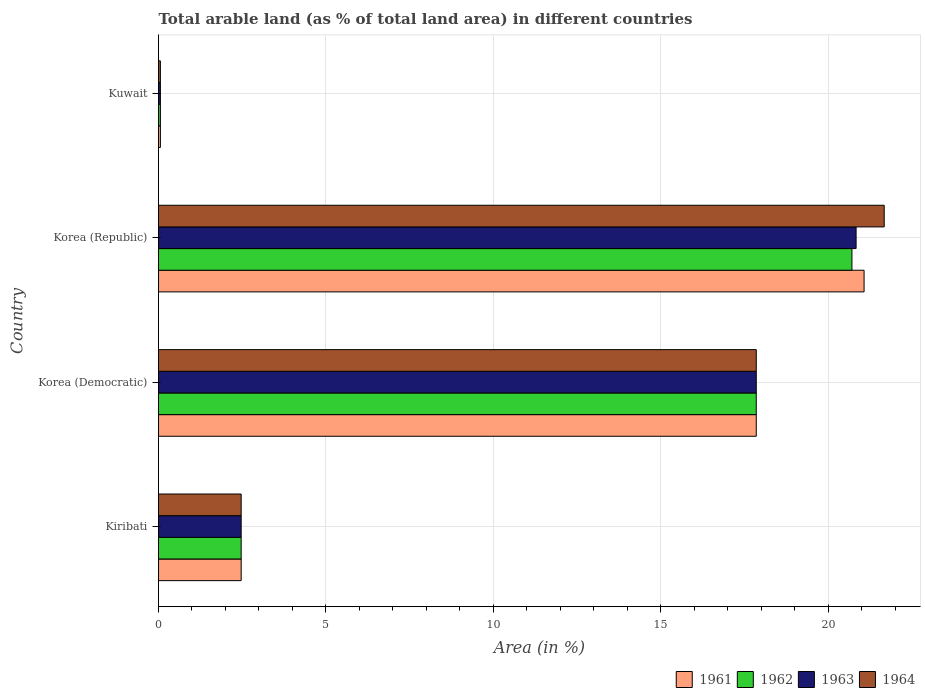How many different coloured bars are there?
Provide a short and direct response. 4. How many groups of bars are there?
Offer a very short reply. 4. Are the number of bars per tick equal to the number of legend labels?
Provide a short and direct response. Yes. Are the number of bars on each tick of the Y-axis equal?
Your response must be concise. Yes. How many bars are there on the 1st tick from the top?
Provide a short and direct response. 4. How many bars are there on the 3rd tick from the bottom?
Keep it short and to the point. 4. What is the label of the 3rd group of bars from the top?
Your answer should be compact. Korea (Democratic). In how many cases, is the number of bars for a given country not equal to the number of legend labels?
Your answer should be compact. 0. What is the percentage of arable land in 1964 in Kuwait?
Provide a succinct answer. 0.06. Across all countries, what is the maximum percentage of arable land in 1962?
Keep it short and to the point. 20.71. Across all countries, what is the minimum percentage of arable land in 1964?
Ensure brevity in your answer.  0.06. In which country was the percentage of arable land in 1964 maximum?
Provide a short and direct response. Korea (Republic). In which country was the percentage of arable land in 1962 minimum?
Your answer should be very brief. Kuwait. What is the total percentage of arable land in 1963 in the graph?
Keep it short and to the point. 41.22. What is the difference between the percentage of arable land in 1964 in Kiribati and that in Korea (Republic)?
Ensure brevity in your answer.  -19.21. What is the difference between the percentage of arable land in 1961 in Kuwait and the percentage of arable land in 1963 in Korea (Republic)?
Keep it short and to the point. -20.78. What is the average percentage of arable land in 1964 per country?
Offer a terse response. 10.51. What is the difference between the percentage of arable land in 1961 and percentage of arable land in 1963 in Kuwait?
Provide a short and direct response. 0. What is the ratio of the percentage of arable land in 1962 in Kiribati to that in Korea (Democratic)?
Keep it short and to the point. 0.14. Is the difference between the percentage of arable land in 1961 in Kiribati and Korea (Republic) greater than the difference between the percentage of arable land in 1963 in Kiribati and Korea (Republic)?
Give a very brief answer. No. What is the difference between the highest and the second highest percentage of arable land in 1962?
Your answer should be very brief. 2.86. What is the difference between the highest and the lowest percentage of arable land in 1963?
Give a very brief answer. 20.78. Is it the case that in every country, the sum of the percentage of arable land in 1964 and percentage of arable land in 1961 is greater than the sum of percentage of arable land in 1963 and percentage of arable land in 1962?
Offer a terse response. No. What does the 4th bar from the bottom in Korea (Democratic) represents?
Provide a succinct answer. 1964. How many bars are there?
Ensure brevity in your answer.  16. Are all the bars in the graph horizontal?
Provide a succinct answer. Yes. What is the difference between two consecutive major ticks on the X-axis?
Offer a very short reply. 5. Does the graph contain any zero values?
Make the answer very short. No. Where does the legend appear in the graph?
Provide a short and direct response. Bottom right. How are the legend labels stacked?
Your answer should be compact. Horizontal. What is the title of the graph?
Your answer should be compact. Total arable land (as % of total land area) in different countries. What is the label or title of the X-axis?
Give a very brief answer. Area (in %). What is the Area (in %) in 1961 in Kiribati?
Keep it short and to the point. 2.47. What is the Area (in %) of 1962 in Kiribati?
Ensure brevity in your answer.  2.47. What is the Area (in %) of 1963 in Kiribati?
Your answer should be compact. 2.47. What is the Area (in %) in 1964 in Kiribati?
Your answer should be very brief. 2.47. What is the Area (in %) of 1961 in Korea (Democratic)?
Your answer should be compact. 17.86. What is the Area (in %) of 1962 in Korea (Democratic)?
Offer a very short reply. 17.86. What is the Area (in %) of 1963 in Korea (Democratic)?
Give a very brief answer. 17.86. What is the Area (in %) of 1964 in Korea (Democratic)?
Provide a succinct answer. 17.86. What is the Area (in %) of 1961 in Korea (Republic)?
Provide a succinct answer. 21.08. What is the Area (in %) in 1962 in Korea (Republic)?
Your response must be concise. 20.71. What is the Area (in %) of 1963 in Korea (Republic)?
Provide a succinct answer. 20.84. What is the Area (in %) in 1964 in Korea (Republic)?
Give a very brief answer. 21.68. What is the Area (in %) of 1961 in Kuwait?
Keep it short and to the point. 0.06. What is the Area (in %) in 1962 in Kuwait?
Provide a succinct answer. 0.06. What is the Area (in %) in 1963 in Kuwait?
Your answer should be compact. 0.06. What is the Area (in %) of 1964 in Kuwait?
Ensure brevity in your answer.  0.06. Across all countries, what is the maximum Area (in %) in 1961?
Keep it short and to the point. 21.08. Across all countries, what is the maximum Area (in %) in 1962?
Offer a very short reply. 20.71. Across all countries, what is the maximum Area (in %) in 1963?
Offer a very short reply. 20.84. Across all countries, what is the maximum Area (in %) of 1964?
Your answer should be very brief. 21.68. Across all countries, what is the minimum Area (in %) in 1961?
Provide a short and direct response. 0.06. Across all countries, what is the minimum Area (in %) of 1962?
Offer a very short reply. 0.06. Across all countries, what is the minimum Area (in %) of 1963?
Your answer should be very brief. 0.06. Across all countries, what is the minimum Area (in %) in 1964?
Your answer should be compact. 0.06. What is the total Area (in %) of 1961 in the graph?
Your answer should be compact. 41.46. What is the total Area (in %) of 1962 in the graph?
Your answer should be compact. 41.09. What is the total Area (in %) in 1963 in the graph?
Your answer should be very brief. 41.22. What is the total Area (in %) in 1964 in the graph?
Ensure brevity in your answer.  42.06. What is the difference between the Area (in %) of 1961 in Kiribati and that in Korea (Democratic)?
Your response must be concise. -15.39. What is the difference between the Area (in %) in 1962 in Kiribati and that in Korea (Democratic)?
Your answer should be very brief. -15.39. What is the difference between the Area (in %) in 1963 in Kiribati and that in Korea (Democratic)?
Your response must be concise. -15.39. What is the difference between the Area (in %) in 1964 in Kiribati and that in Korea (Democratic)?
Provide a short and direct response. -15.39. What is the difference between the Area (in %) in 1961 in Kiribati and that in Korea (Republic)?
Your answer should be compact. -18.61. What is the difference between the Area (in %) of 1962 in Kiribati and that in Korea (Republic)?
Give a very brief answer. -18.24. What is the difference between the Area (in %) in 1963 in Kiribati and that in Korea (Republic)?
Make the answer very short. -18.37. What is the difference between the Area (in %) in 1964 in Kiribati and that in Korea (Republic)?
Offer a very short reply. -19.21. What is the difference between the Area (in %) of 1961 in Kiribati and that in Kuwait?
Your answer should be compact. 2.41. What is the difference between the Area (in %) in 1962 in Kiribati and that in Kuwait?
Keep it short and to the point. 2.41. What is the difference between the Area (in %) of 1963 in Kiribati and that in Kuwait?
Offer a very short reply. 2.41. What is the difference between the Area (in %) of 1964 in Kiribati and that in Kuwait?
Offer a very short reply. 2.41. What is the difference between the Area (in %) of 1961 in Korea (Democratic) and that in Korea (Republic)?
Ensure brevity in your answer.  -3.22. What is the difference between the Area (in %) of 1962 in Korea (Democratic) and that in Korea (Republic)?
Your response must be concise. -2.86. What is the difference between the Area (in %) in 1963 in Korea (Democratic) and that in Korea (Republic)?
Provide a short and direct response. -2.98. What is the difference between the Area (in %) of 1964 in Korea (Democratic) and that in Korea (Republic)?
Offer a terse response. -3.82. What is the difference between the Area (in %) in 1961 in Korea (Democratic) and that in Kuwait?
Your answer should be compact. 17.8. What is the difference between the Area (in %) in 1962 in Korea (Democratic) and that in Kuwait?
Offer a terse response. 17.8. What is the difference between the Area (in %) of 1963 in Korea (Democratic) and that in Kuwait?
Offer a terse response. 17.8. What is the difference between the Area (in %) of 1964 in Korea (Democratic) and that in Kuwait?
Make the answer very short. 17.8. What is the difference between the Area (in %) of 1961 in Korea (Republic) and that in Kuwait?
Your answer should be compact. 21.02. What is the difference between the Area (in %) of 1962 in Korea (Republic) and that in Kuwait?
Provide a succinct answer. 20.66. What is the difference between the Area (in %) in 1963 in Korea (Republic) and that in Kuwait?
Keep it short and to the point. 20.78. What is the difference between the Area (in %) of 1964 in Korea (Republic) and that in Kuwait?
Provide a succinct answer. 21.62. What is the difference between the Area (in %) of 1961 in Kiribati and the Area (in %) of 1962 in Korea (Democratic)?
Give a very brief answer. -15.39. What is the difference between the Area (in %) of 1961 in Kiribati and the Area (in %) of 1963 in Korea (Democratic)?
Keep it short and to the point. -15.39. What is the difference between the Area (in %) of 1961 in Kiribati and the Area (in %) of 1964 in Korea (Democratic)?
Your answer should be very brief. -15.39. What is the difference between the Area (in %) of 1962 in Kiribati and the Area (in %) of 1963 in Korea (Democratic)?
Give a very brief answer. -15.39. What is the difference between the Area (in %) of 1962 in Kiribati and the Area (in %) of 1964 in Korea (Democratic)?
Your response must be concise. -15.39. What is the difference between the Area (in %) in 1963 in Kiribati and the Area (in %) in 1964 in Korea (Democratic)?
Give a very brief answer. -15.39. What is the difference between the Area (in %) in 1961 in Kiribati and the Area (in %) in 1962 in Korea (Republic)?
Provide a short and direct response. -18.24. What is the difference between the Area (in %) in 1961 in Kiribati and the Area (in %) in 1963 in Korea (Republic)?
Keep it short and to the point. -18.37. What is the difference between the Area (in %) in 1961 in Kiribati and the Area (in %) in 1964 in Korea (Republic)?
Offer a terse response. -19.21. What is the difference between the Area (in %) of 1962 in Kiribati and the Area (in %) of 1963 in Korea (Republic)?
Your answer should be compact. -18.37. What is the difference between the Area (in %) in 1962 in Kiribati and the Area (in %) in 1964 in Korea (Republic)?
Your answer should be very brief. -19.21. What is the difference between the Area (in %) of 1963 in Kiribati and the Area (in %) of 1964 in Korea (Republic)?
Offer a terse response. -19.21. What is the difference between the Area (in %) in 1961 in Kiribati and the Area (in %) in 1962 in Kuwait?
Your answer should be compact. 2.41. What is the difference between the Area (in %) of 1961 in Kiribati and the Area (in %) of 1963 in Kuwait?
Offer a very short reply. 2.41. What is the difference between the Area (in %) in 1961 in Kiribati and the Area (in %) in 1964 in Kuwait?
Provide a short and direct response. 2.41. What is the difference between the Area (in %) in 1962 in Kiribati and the Area (in %) in 1963 in Kuwait?
Your answer should be compact. 2.41. What is the difference between the Area (in %) of 1962 in Kiribati and the Area (in %) of 1964 in Kuwait?
Offer a terse response. 2.41. What is the difference between the Area (in %) in 1963 in Kiribati and the Area (in %) in 1964 in Kuwait?
Your answer should be compact. 2.41. What is the difference between the Area (in %) of 1961 in Korea (Democratic) and the Area (in %) of 1962 in Korea (Republic)?
Provide a short and direct response. -2.86. What is the difference between the Area (in %) in 1961 in Korea (Democratic) and the Area (in %) in 1963 in Korea (Republic)?
Ensure brevity in your answer.  -2.98. What is the difference between the Area (in %) of 1961 in Korea (Democratic) and the Area (in %) of 1964 in Korea (Republic)?
Provide a succinct answer. -3.82. What is the difference between the Area (in %) of 1962 in Korea (Democratic) and the Area (in %) of 1963 in Korea (Republic)?
Give a very brief answer. -2.98. What is the difference between the Area (in %) in 1962 in Korea (Democratic) and the Area (in %) in 1964 in Korea (Republic)?
Keep it short and to the point. -3.82. What is the difference between the Area (in %) of 1963 in Korea (Democratic) and the Area (in %) of 1964 in Korea (Republic)?
Provide a succinct answer. -3.82. What is the difference between the Area (in %) of 1961 in Korea (Democratic) and the Area (in %) of 1962 in Kuwait?
Your answer should be very brief. 17.8. What is the difference between the Area (in %) of 1961 in Korea (Democratic) and the Area (in %) of 1963 in Kuwait?
Give a very brief answer. 17.8. What is the difference between the Area (in %) of 1961 in Korea (Democratic) and the Area (in %) of 1964 in Kuwait?
Ensure brevity in your answer.  17.8. What is the difference between the Area (in %) of 1962 in Korea (Democratic) and the Area (in %) of 1963 in Kuwait?
Give a very brief answer. 17.8. What is the difference between the Area (in %) in 1962 in Korea (Democratic) and the Area (in %) in 1964 in Kuwait?
Ensure brevity in your answer.  17.8. What is the difference between the Area (in %) of 1963 in Korea (Democratic) and the Area (in %) of 1964 in Kuwait?
Keep it short and to the point. 17.8. What is the difference between the Area (in %) in 1961 in Korea (Republic) and the Area (in %) in 1962 in Kuwait?
Offer a very short reply. 21.02. What is the difference between the Area (in %) of 1961 in Korea (Republic) and the Area (in %) of 1963 in Kuwait?
Ensure brevity in your answer.  21.02. What is the difference between the Area (in %) in 1961 in Korea (Republic) and the Area (in %) in 1964 in Kuwait?
Ensure brevity in your answer.  21.02. What is the difference between the Area (in %) in 1962 in Korea (Republic) and the Area (in %) in 1963 in Kuwait?
Your response must be concise. 20.66. What is the difference between the Area (in %) in 1962 in Korea (Republic) and the Area (in %) in 1964 in Kuwait?
Offer a terse response. 20.66. What is the difference between the Area (in %) of 1963 in Korea (Republic) and the Area (in %) of 1964 in Kuwait?
Ensure brevity in your answer.  20.78. What is the average Area (in %) of 1961 per country?
Offer a very short reply. 10.36. What is the average Area (in %) in 1962 per country?
Provide a succinct answer. 10.27. What is the average Area (in %) of 1963 per country?
Make the answer very short. 10.3. What is the average Area (in %) of 1964 per country?
Make the answer very short. 10.51. What is the difference between the Area (in %) in 1961 and Area (in %) in 1964 in Kiribati?
Ensure brevity in your answer.  0. What is the difference between the Area (in %) in 1962 and Area (in %) in 1964 in Kiribati?
Offer a terse response. 0. What is the difference between the Area (in %) in 1961 and Area (in %) in 1963 in Korea (Democratic)?
Offer a terse response. 0. What is the difference between the Area (in %) in 1962 and Area (in %) in 1963 in Korea (Democratic)?
Your answer should be compact. 0. What is the difference between the Area (in %) of 1963 and Area (in %) of 1964 in Korea (Democratic)?
Give a very brief answer. 0. What is the difference between the Area (in %) in 1961 and Area (in %) in 1962 in Korea (Republic)?
Ensure brevity in your answer.  0.36. What is the difference between the Area (in %) in 1961 and Area (in %) in 1963 in Korea (Republic)?
Provide a succinct answer. 0.24. What is the difference between the Area (in %) in 1961 and Area (in %) in 1964 in Korea (Republic)?
Provide a short and direct response. -0.6. What is the difference between the Area (in %) of 1962 and Area (in %) of 1963 in Korea (Republic)?
Keep it short and to the point. -0.12. What is the difference between the Area (in %) in 1962 and Area (in %) in 1964 in Korea (Republic)?
Your answer should be compact. -0.96. What is the difference between the Area (in %) of 1963 and Area (in %) of 1964 in Korea (Republic)?
Your answer should be very brief. -0.84. What is the difference between the Area (in %) of 1961 and Area (in %) of 1962 in Kuwait?
Your answer should be compact. 0. What is the difference between the Area (in %) in 1962 and Area (in %) in 1964 in Kuwait?
Give a very brief answer. 0. What is the difference between the Area (in %) of 1963 and Area (in %) of 1964 in Kuwait?
Provide a short and direct response. 0. What is the ratio of the Area (in %) in 1961 in Kiribati to that in Korea (Democratic)?
Give a very brief answer. 0.14. What is the ratio of the Area (in %) in 1962 in Kiribati to that in Korea (Democratic)?
Your answer should be very brief. 0.14. What is the ratio of the Area (in %) of 1963 in Kiribati to that in Korea (Democratic)?
Ensure brevity in your answer.  0.14. What is the ratio of the Area (in %) in 1964 in Kiribati to that in Korea (Democratic)?
Ensure brevity in your answer.  0.14. What is the ratio of the Area (in %) of 1961 in Kiribati to that in Korea (Republic)?
Provide a succinct answer. 0.12. What is the ratio of the Area (in %) in 1962 in Kiribati to that in Korea (Republic)?
Your response must be concise. 0.12. What is the ratio of the Area (in %) in 1963 in Kiribati to that in Korea (Republic)?
Ensure brevity in your answer.  0.12. What is the ratio of the Area (in %) in 1964 in Kiribati to that in Korea (Republic)?
Your answer should be very brief. 0.11. What is the ratio of the Area (in %) of 1961 in Kiribati to that in Kuwait?
Offer a terse response. 44. What is the ratio of the Area (in %) of 1964 in Kiribati to that in Kuwait?
Offer a very short reply. 44. What is the ratio of the Area (in %) of 1961 in Korea (Democratic) to that in Korea (Republic)?
Provide a short and direct response. 0.85. What is the ratio of the Area (in %) in 1962 in Korea (Democratic) to that in Korea (Republic)?
Provide a succinct answer. 0.86. What is the ratio of the Area (in %) in 1963 in Korea (Democratic) to that in Korea (Republic)?
Your answer should be compact. 0.86. What is the ratio of the Area (in %) in 1964 in Korea (Democratic) to that in Korea (Republic)?
Your answer should be very brief. 0.82. What is the ratio of the Area (in %) in 1961 in Korea (Democratic) to that in Kuwait?
Provide a succinct answer. 318.19. What is the ratio of the Area (in %) in 1962 in Korea (Democratic) to that in Kuwait?
Keep it short and to the point. 318.19. What is the ratio of the Area (in %) in 1963 in Korea (Democratic) to that in Kuwait?
Make the answer very short. 318.19. What is the ratio of the Area (in %) of 1964 in Korea (Democratic) to that in Kuwait?
Offer a very short reply. 318.19. What is the ratio of the Area (in %) in 1961 in Korea (Republic) to that in Kuwait?
Make the answer very short. 375.58. What is the ratio of the Area (in %) in 1962 in Korea (Republic) to that in Kuwait?
Provide a succinct answer. 369.11. What is the ratio of the Area (in %) in 1963 in Korea (Republic) to that in Kuwait?
Offer a very short reply. 371.33. What is the ratio of the Area (in %) of 1964 in Korea (Republic) to that in Kuwait?
Ensure brevity in your answer.  386.29. What is the difference between the highest and the second highest Area (in %) in 1961?
Provide a succinct answer. 3.22. What is the difference between the highest and the second highest Area (in %) in 1962?
Provide a succinct answer. 2.86. What is the difference between the highest and the second highest Area (in %) of 1963?
Keep it short and to the point. 2.98. What is the difference between the highest and the second highest Area (in %) of 1964?
Give a very brief answer. 3.82. What is the difference between the highest and the lowest Area (in %) in 1961?
Provide a short and direct response. 21.02. What is the difference between the highest and the lowest Area (in %) in 1962?
Provide a succinct answer. 20.66. What is the difference between the highest and the lowest Area (in %) in 1963?
Your answer should be compact. 20.78. What is the difference between the highest and the lowest Area (in %) in 1964?
Your response must be concise. 21.62. 